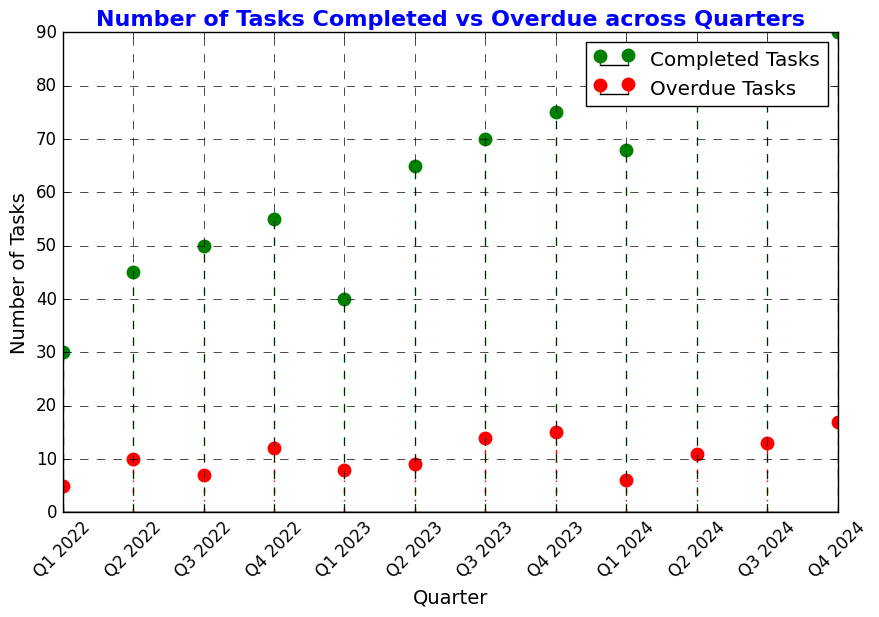What is the highest number of completed tasks in any quarter? To find the highest number of completed tasks, we need to look for the tallest green stem in the plot. The tall green stem represents Q4 2024 with 90 completed tasks.
Answer: 90 In which quarter were the number of overdue tasks the lowest? The lowest red stem represents the smallest number of overdue tasks. The shortest red stem, which is Q1 2022, indicates 5 overdue tasks.
Answer: Q1 2022 How does the number of completed tasks in Q2 2022 compare to the number of overdue tasks in the same quarter? To compare these values, we look at Q2 2022. The plot shows 45 completed tasks (green stem) and 10 overdue tasks (red stem). Hence, the completed tasks are greater.
Answer: Completed tasks are greater What is the average number of overdue tasks per quarter from Q1 2022 to Q4 2022? To calculate the average, sum the overdue tasks from Q1 2022 to Q4 2022 and divide by 4. (5 + 10 + 7 + 12) / 4 = 34 / 4 = 8.5
Answer: 8.5 Is there any quarter where the number of completed tasks decreased compared to the previous quarter? If so, which one? Look across the green stems and check if there is any decrease from one quarter to the next. From Q4 2022 (55) to Q1 2023 (40), the completed tasks decrease.
Answer: Q1 2023 What is the total number of completed tasks in 2023? Sum the numbers of completed tasks for all quarters in 2023: 40 (Q1) + 65 (Q2) + 70 (Q3) + 75 (Q4) = 250.
Answer: 250 Compare the visual width and color representation of the stems for completed and overdue tasks. Completed tasks are represented by green stems with wider markers, and overdue tasks by red stems with the same width markers but different line styles.
Answer: Green for completed, red for overdue Which quarter has the greatest number of both completed and overdue tasks combined? Sum completed and overdue tasks for each quarter and identify the highest sum. Q4 2024 has the highest combined total (90 + 17 = 107).
Answer: Q4 2024 What is the range of completed tasks from Q1 2022 to Q4 2024? Subtract the minimum value of completed tasks from the maximum value of completed tasks. The minimum is 30 (Q1 2022) and the maximum is 90 (Q4 2024), so the range is 90 - 30 = 60.
Answer: 60 